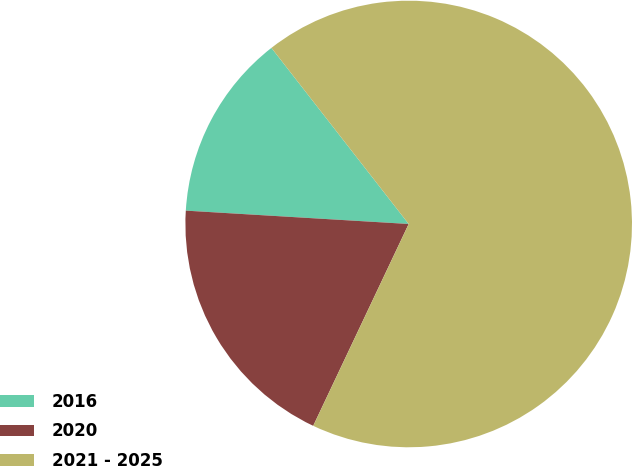Convert chart to OTSL. <chart><loc_0><loc_0><loc_500><loc_500><pie_chart><fcel>2016<fcel>2020<fcel>2021 - 2025<nl><fcel>13.51%<fcel>18.92%<fcel>67.57%<nl></chart> 